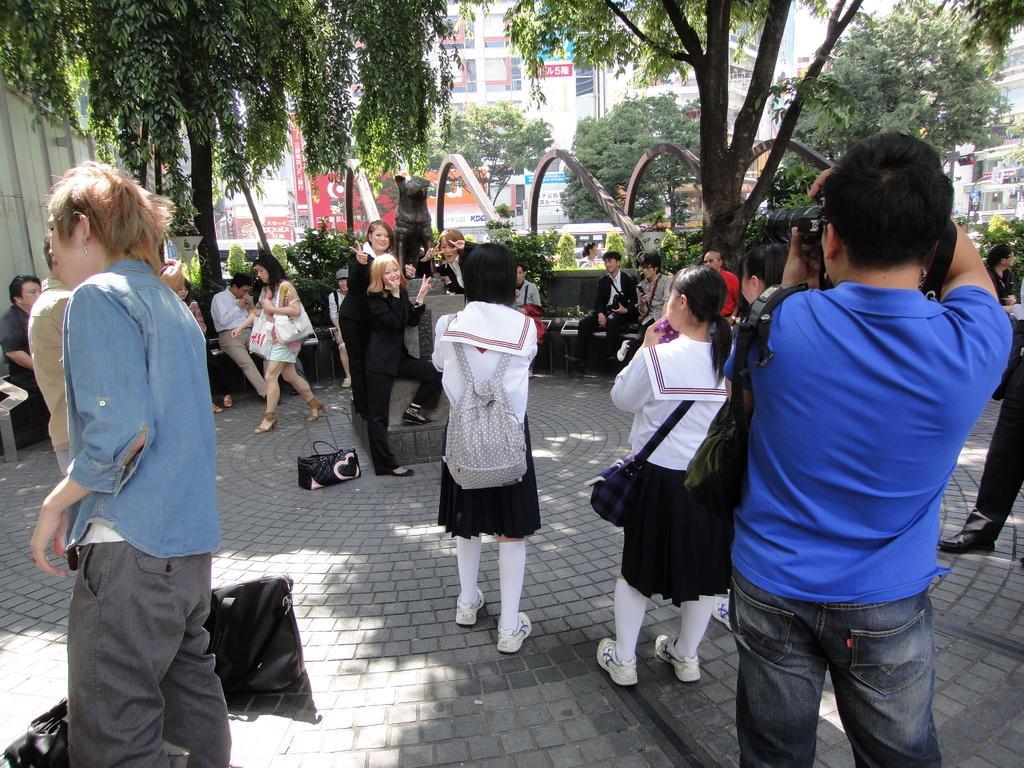In one or two sentences, can you explain what this image depicts? In this image, there are a few people. Among them, some people are sitting on benches. We can see the ground with some objects. We can also see a statue and some metallic objects. There are a few trees and plants. We can also see some buildings and boards with text. We can also see a white colored object and a traffic light. 